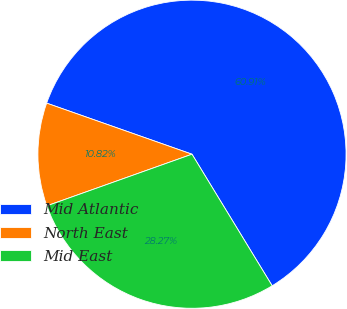<chart> <loc_0><loc_0><loc_500><loc_500><pie_chart><fcel>Mid Atlantic<fcel>North East<fcel>Mid East<nl><fcel>60.91%<fcel>10.82%<fcel>28.27%<nl></chart> 